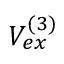Convert formula to latex. <formula><loc_0><loc_0><loc_500><loc_500>V _ { e x } ^ { ( 3 ) }</formula> 